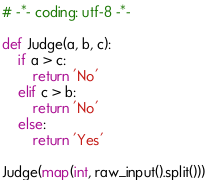<code> <loc_0><loc_0><loc_500><loc_500><_Python_># -*- coding: utf-8 -*-

def Judge(a, b, c):
    if a > c:
        return 'No'
    elif c > b:
        return 'No'
    else:
        return 'Yes'

Judge(map(int, raw_input().split()))
</code> 